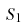<formula> <loc_0><loc_0><loc_500><loc_500>S _ { 1 }</formula> 